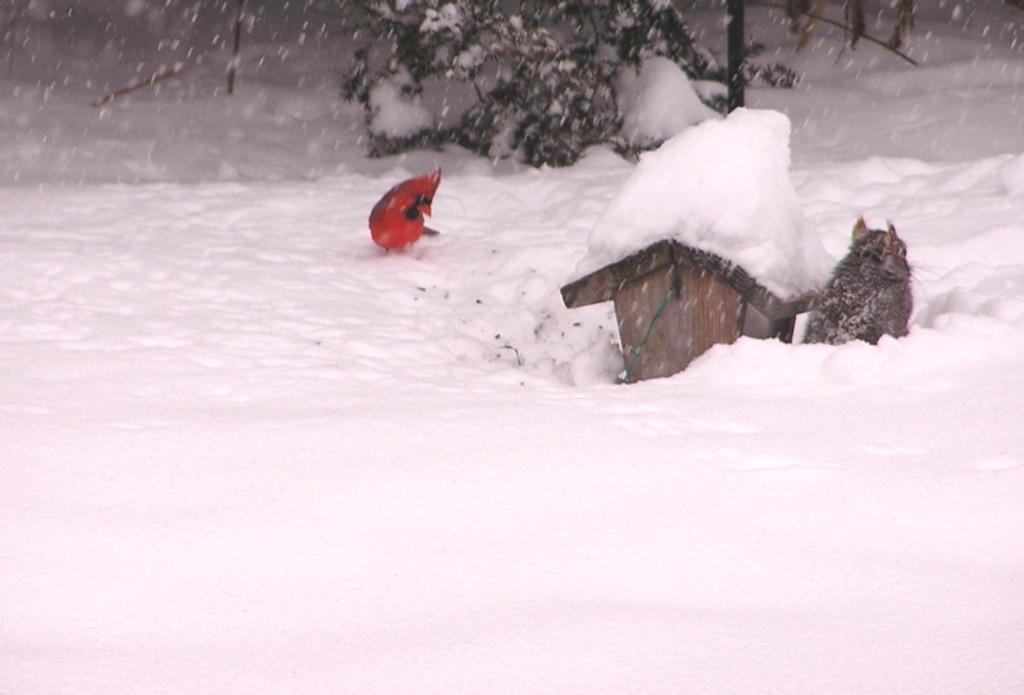What type of animal can be seen in the image? There is a bird in the image. What other animal is present in the image? There is a cat in the image. What structure is visible in the image? There is a bird house in the image. Where are the bird, cat, and bird house located in the image? They are on the snow. What can be seen in the background of the image? There is a plant in the background of the image. What type of ornament is hanging from the bird house in the image? There is no ornament hanging from the bird house in the image. What type of mine can be seen in the background of the image? There is no mine present in the image; it features a bird, cat, bird house, and plant on the snow. 